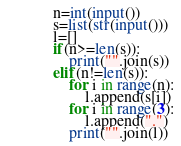<code> <loc_0><loc_0><loc_500><loc_500><_Python_>n=int(input())
s=list(str(input()))
l=[]
if(n>=len(s)):
    print("".join(s))
elif(n!=len(s)):
    for i in range(n):
        l.append(s[i])
    for i in range(3):
        l.append(".")
    print("".join(l))</code> 